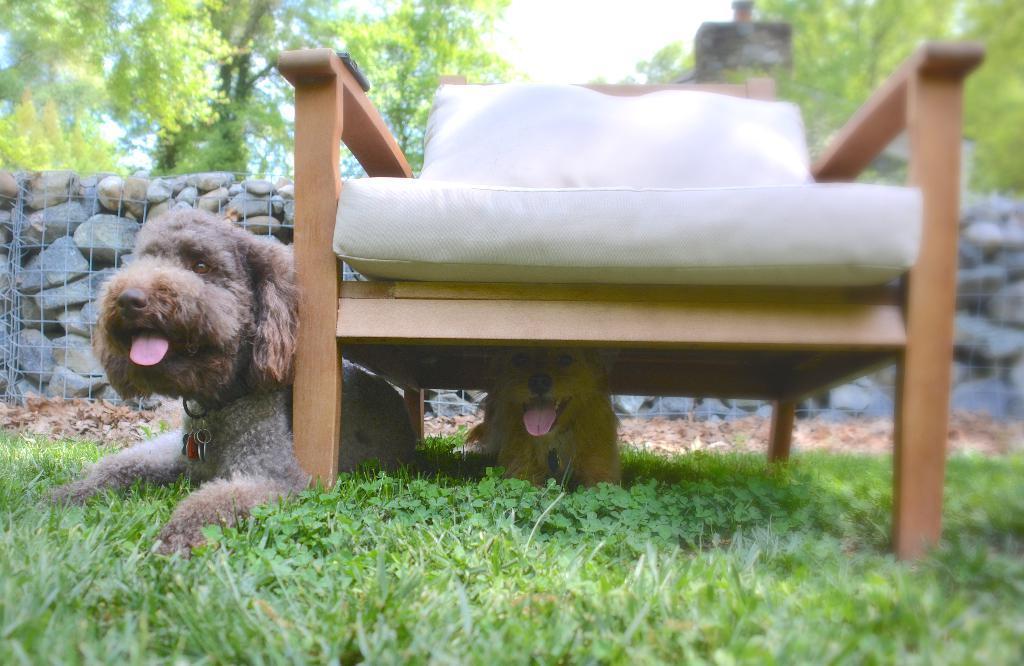In one or two sentences, can you explain what this image depicts? In this Image I see 2 dogs and one dog under the chair and they are sitting on the grass. In the background I see the stones and the trees. 